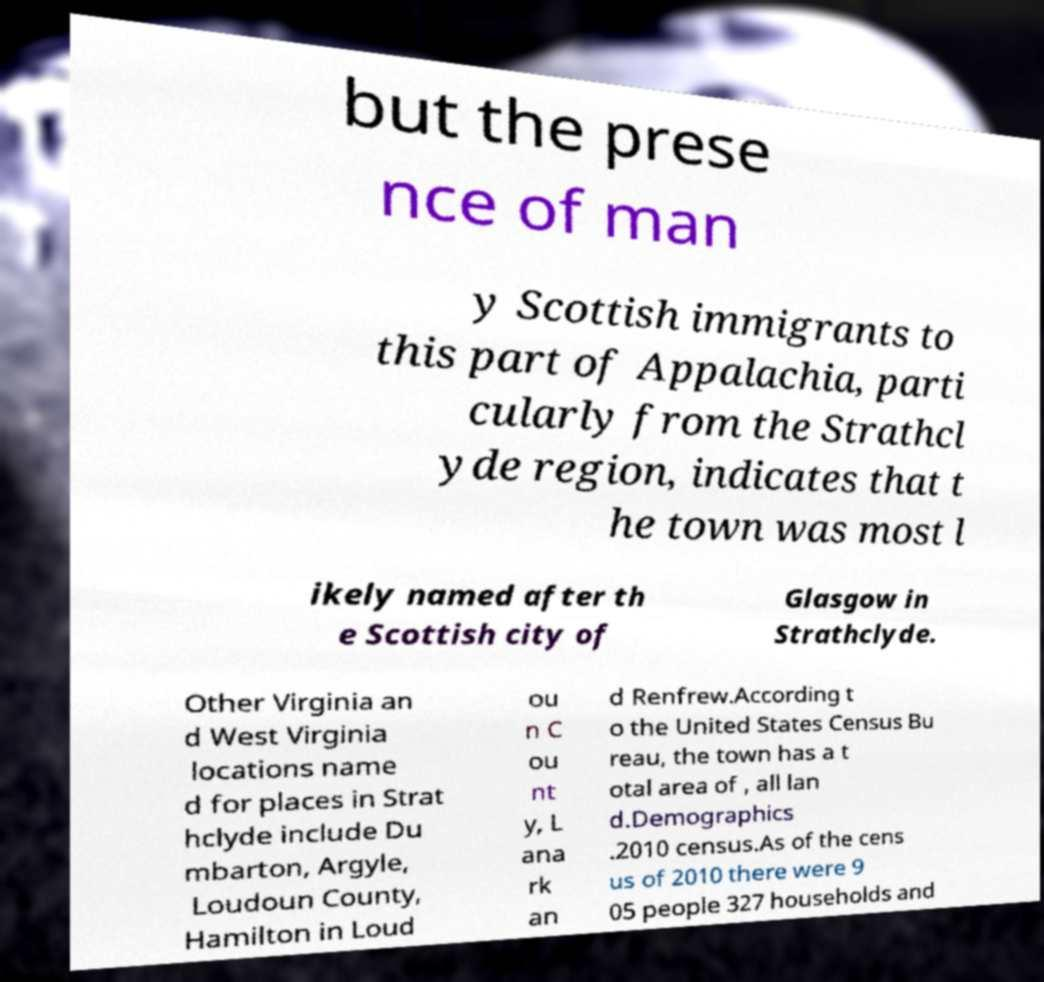I need the written content from this picture converted into text. Can you do that? but the prese nce of man y Scottish immigrants to this part of Appalachia, parti cularly from the Strathcl yde region, indicates that t he town was most l ikely named after th e Scottish city of Glasgow in Strathclyde. Other Virginia an d West Virginia locations name d for places in Strat hclyde include Du mbarton, Argyle, Loudoun County, Hamilton in Loud ou n C ou nt y, L ana rk an d Renfrew.According t o the United States Census Bu reau, the town has a t otal area of , all lan d.Demographics .2010 census.As of the cens us of 2010 there were 9 05 people 327 households and 